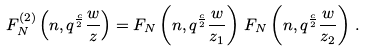<formula> <loc_0><loc_0><loc_500><loc_500>F _ { N } ^ { ( 2 ) } \left ( n , q ^ { \frac { c } { 2 } } \frac { w } { z } \right ) = F _ { N } \left ( n , q ^ { \frac { c } { 2 } } \frac { w } { z _ { 1 } } \right ) \, F _ { N } \left ( n , q ^ { \frac { c } { 2 } } \frac { w } { z _ { 2 } } \right ) \, .</formula> 